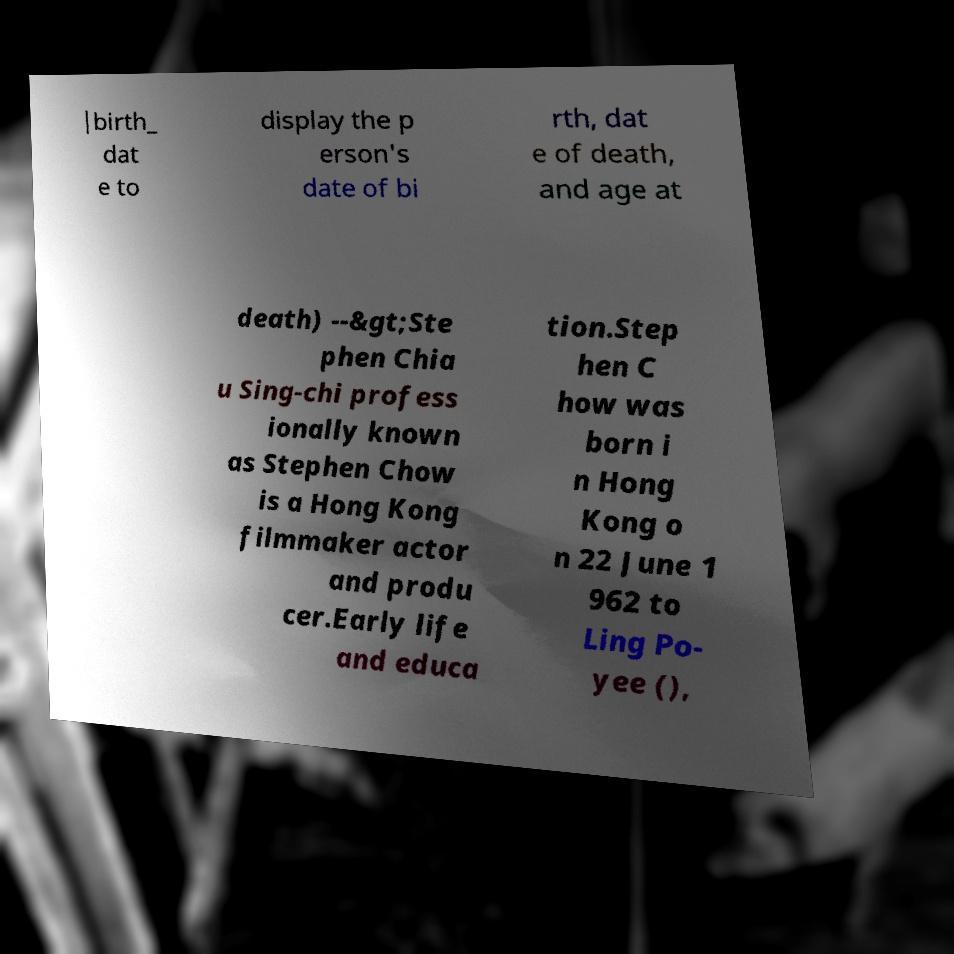Please identify and transcribe the text found in this image. |birth_ dat e to display the p erson's date of bi rth, dat e of death, and age at death) --&gt;Ste phen Chia u Sing-chi profess ionally known as Stephen Chow is a Hong Kong filmmaker actor and produ cer.Early life and educa tion.Step hen C how was born i n Hong Kong o n 22 June 1 962 to Ling Po- yee (), 